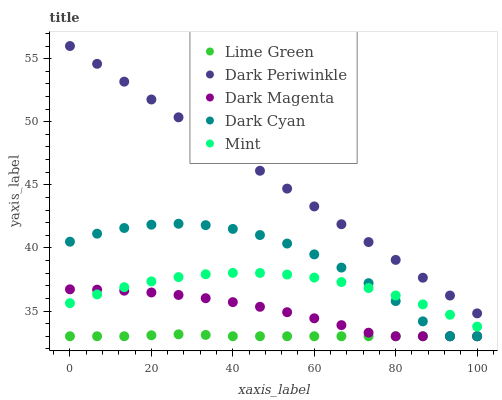Does Lime Green have the minimum area under the curve?
Answer yes or no. Yes. Does Dark Periwinkle have the maximum area under the curve?
Answer yes or no. Yes. Does Mint have the minimum area under the curve?
Answer yes or no. No. Does Mint have the maximum area under the curve?
Answer yes or no. No. Is Dark Periwinkle the smoothest?
Answer yes or no. Yes. Is Dark Cyan the roughest?
Answer yes or no. Yes. Is Mint the smoothest?
Answer yes or no. No. Is Mint the roughest?
Answer yes or no. No. Does Dark Cyan have the lowest value?
Answer yes or no. Yes. Does Mint have the lowest value?
Answer yes or no. No. Does Dark Periwinkle have the highest value?
Answer yes or no. Yes. Does Mint have the highest value?
Answer yes or no. No. Is Dark Cyan less than Dark Periwinkle?
Answer yes or no. Yes. Is Dark Periwinkle greater than Mint?
Answer yes or no. Yes. Does Mint intersect Dark Cyan?
Answer yes or no. Yes. Is Mint less than Dark Cyan?
Answer yes or no. No. Is Mint greater than Dark Cyan?
Answer yes or no. No. Does Dark Cyan intersect Dark Periwinkle?
Answer yes or no. No. 